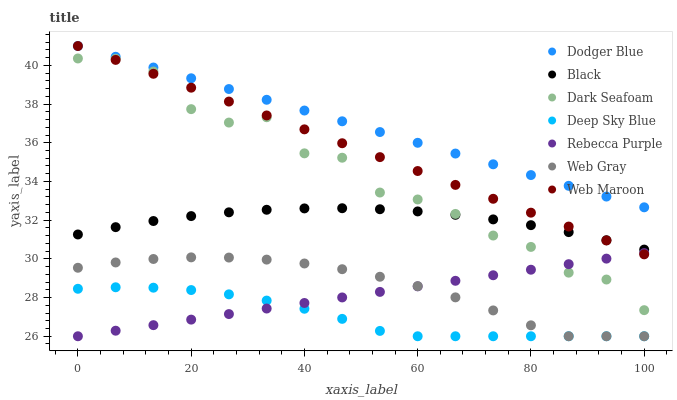Does Deep Sky Blue have the minimum area under the curve?
Answer yes or no. Yes. Does Dodger Blue have the maximum area under the curve?
Answer yes or no. Yes. Does Web Maroon have the minimum area under the curve?
Answer yes or no. No. Does Web Maroon have the maximum area under the curve?
Answer yes or no. No. Is Dodger Blue the smoothest?
Answer yes or no. Yes. Is Dark Seafoam the roughest?
Answer yes or no. Yes. Is Web Maroon the smoothest?
Answer yes or no. No. Is Web Maroon the roughest?
Answer yes or no. No. Does Web Gray have the lowest value?
Answer yes or no. Yes. Does Web Maroon have the lowest value?
Answer yes or no. No. Does Dodger Blue have the highest value?
Answer yes or no. Yes. Does Dark Seafoam have the highest value?
Answer yes or no. No. Is Black less than Dodger Blue?
Answer yes or no. Yes. Is Web Maroon greater than Web Gray?
Answer yes or no. Yes. Does Dark Seafoam intersect Rebecca Purple?
Answer yes or no. Yes. Is Dark Seafoam less than Rebecca Purple?
Answer yes or no. No. Is Dark Seafoam greater than Rebecca Purple?
Answer yes or no. No. Does Black intersect Dodger Blue?
Answer yes or no. No. 